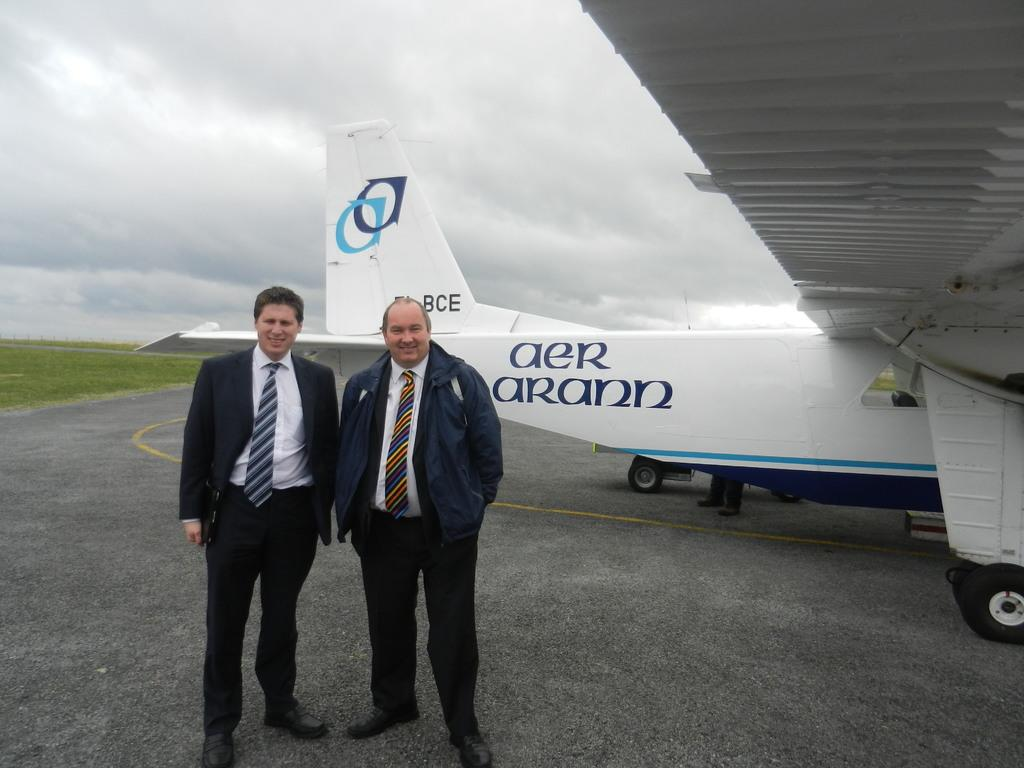<image>
Create a compact narrative representing the image presented. two men stand in front of an Aer Arann plane 